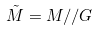<formula> <loc_0><loc_0><loc_500><loc_500>\tilde { M } = M / / G</formula> 